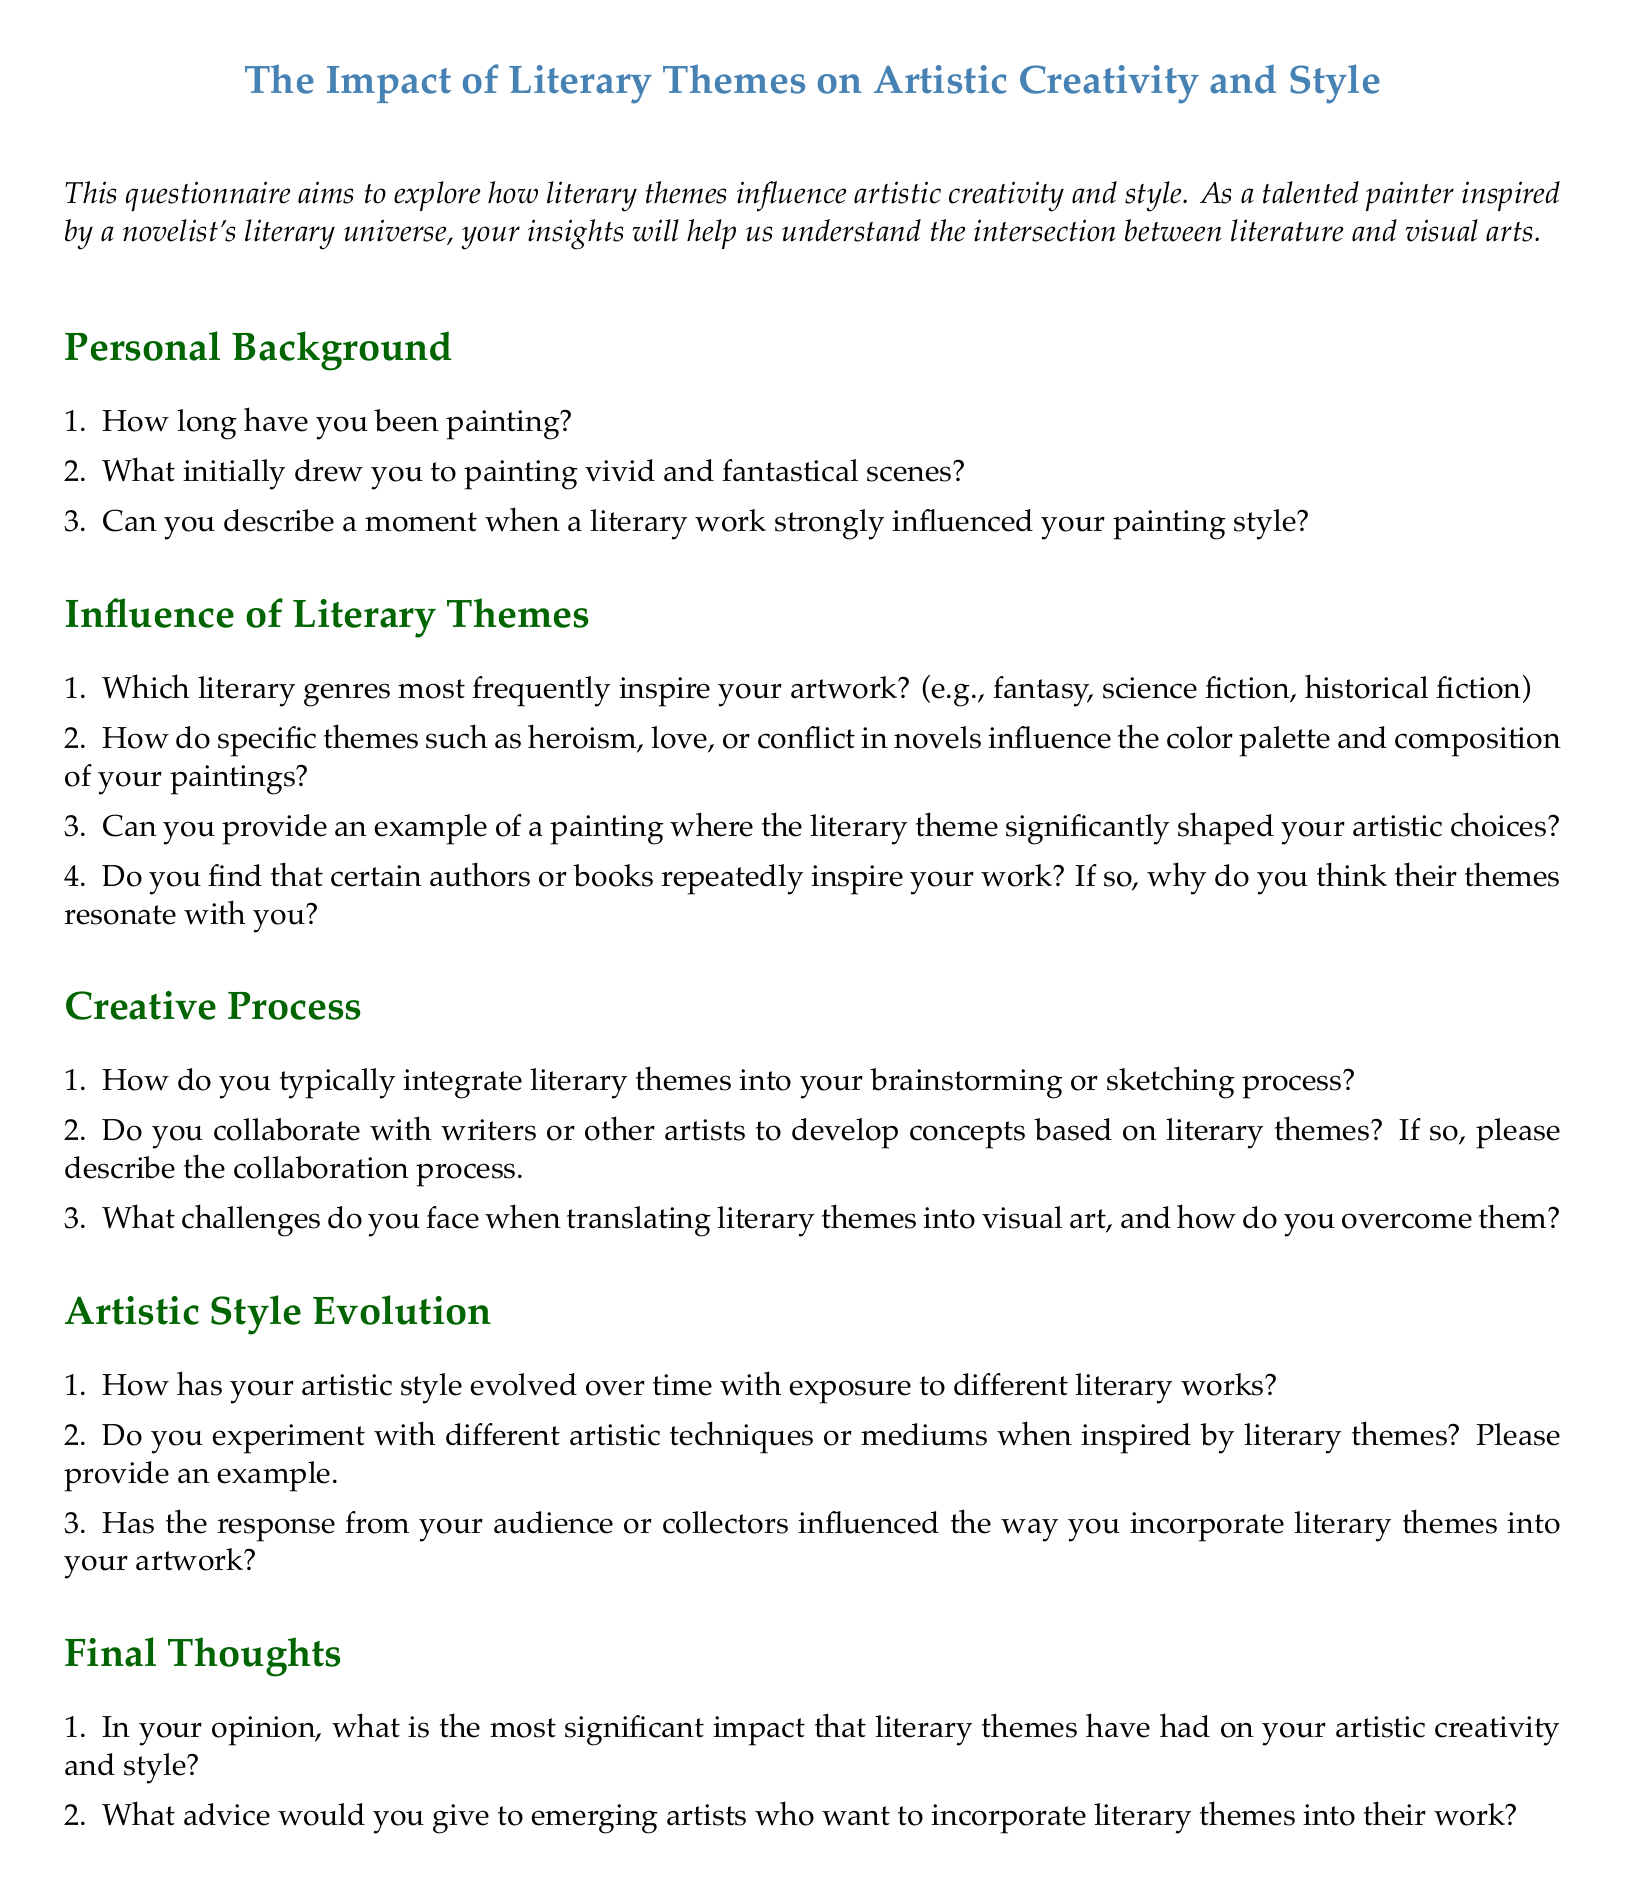What is the title of the questionnaire? The title is prominently displayed at the top of the document.
Answer: The Impact of Literary Themes on Artistic Creativity and Style How many main sections are in the questionnaire? The document is structured into several distinct sections related to various topics.
Answer: Five What color is used for the section titles? The section titles are differentiated by a specific color outline in the document.
Answer: Green Which literary genres are mentioned as sources of inspiration? The questionnaire asks specifically about literary genres that inspire artwork.
Answer: Fantasy, science fiction, historical fiction What advice is given to emerging artists? The last section poses a question specifically seeking advice for new artists.
Answer: Incorporate literary themes How does the document suggest overcoming challenges in art? The questionnaire inquires about solutions to challenges faced in translating literary themes into visuals.
Answer: It asks for a description of how challenges are overcome What is the main purpose of the questionnaire? The introductory text provides a clear intent for the document.
Answer: To explore how literary themes influence artistic creativity and style How can literary themes affect color palette choices? The questionnaire specifically asks how themes influence artistic elements like color choice.
Answer: It influences the color palette and composition of paintings What is one example of a question about the creative process? The section on the creative process contains multiple specific inquiries about integrating themes.
Answer: How do you typically integrate literary themes into your brainstorming or sketching process? 